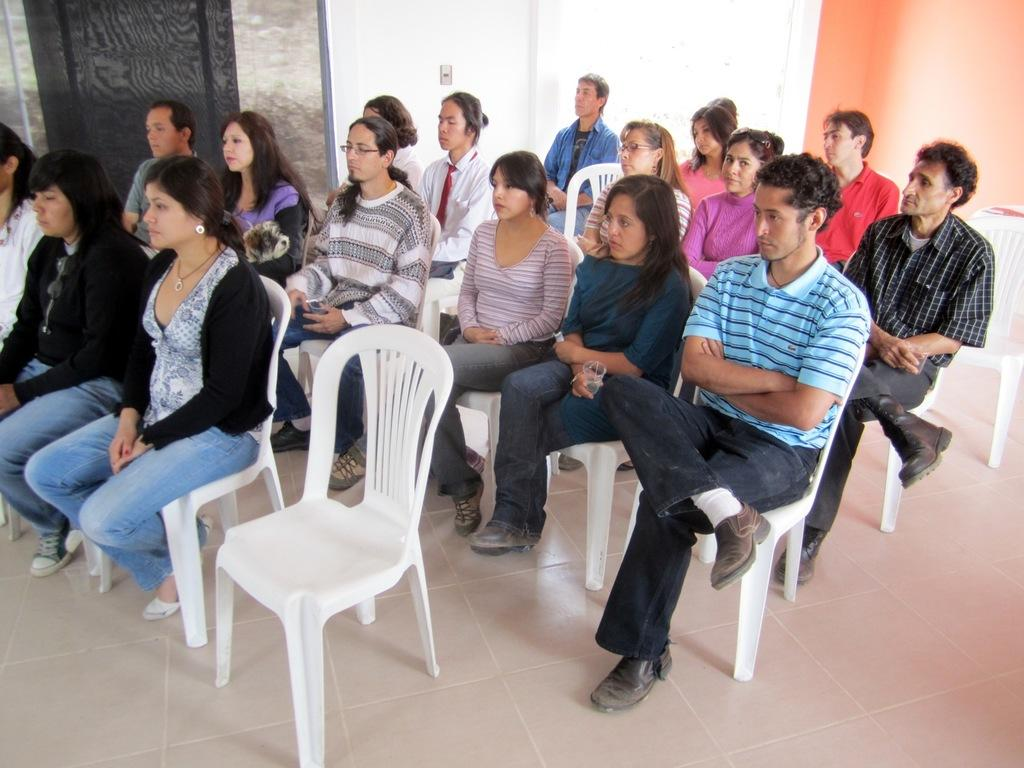How many people are in the image? There is a group of people in the image. What are the people doing in the image? The people are sitting on chairs. What are the people looking at in the image? The people are looking at something. What type of mass can be seen in the image? There is no mass present in the image; it features a group of people sitting on chairs and looking at something. What type of blade is being used in the argument in the image? There is no argument or blade present in the image. 